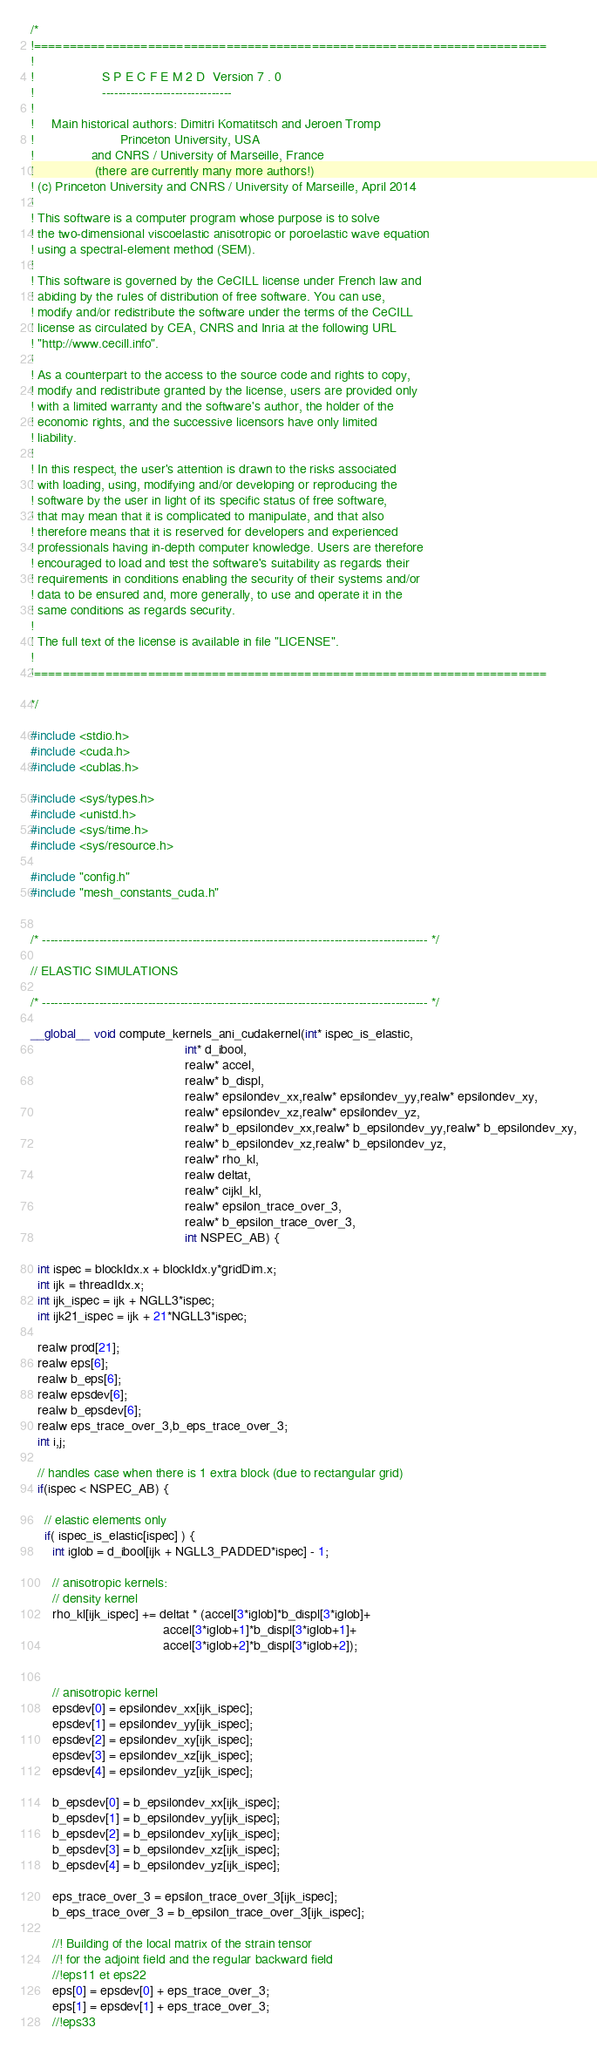Convert code to text. <code><loc_0><loc_0><loc_500><loc_500><_Cuda_>/*
!========================================================================
!
!                   S P E C F E M 2 D  Version 7 . 0
!                   --------------------------------
!
!     Main historical authors: Dimitri Komatitsch and Jeroen Tromp
!                        Princeton University, USA
!                and CNRS / University of Marseille, France
!                 (there are currently many more authors!)
! (c) Princeton University and CNRS / University of Marseille, April 2014
!
! This software is a computer program whose purpose is to solve
! the two-dimensional viscoelastic anisotropic or poroelastic wave equation
! using a spectral-element method (SEM).
!
! This software is governed by the CeCILL license under French law and
! abiding by the rules of distribution of free software. You can use,
! modify and/or redistribute the software under the terms of the CeCILL
! license as circulated by CEA, CNRS and Inria at the following URL
! "http://www.cecill.info".
!
! As a counterpart to the access to the source code and rights to copy,
! modify and redistribute granted by the license, users are provided only
! with a limited warranty and the software's author, the holder of the
! economic rights, and the successive licensors have only limited
! liability.
!
! In this respect, the user's attention is drawn to the risks associated
! with loading, using, modifying and/or developing or reproducing the
! software by the user in light of its specific status of free software,
! that may mean that it is complicated to manipulate, and that also
! therefore means that it is reserved for developers and experienced
! professionals having in-depth computer knowledge. Users are therefore
! encouraged to load and test the software's suitability as regards their
! requirements in conditions enabling the security of their systems and/or
! data to be ensured and, more generally, to use and operate it in the
! same conditions as regards security.
!
! The full text of the license is available in file "LICENSE".
!
!========================================================================

*/

#include <stdio.h>
#include <cuda.h>
#include <cublas.h>

#include <sys/types.h>
#include <unistd.h>
#include <sys/time.h>
#include <sys/resource.h>

#include "config.h"
#include "mesh_constants_cuda.h"


/* ----------------------------------------------------------------------------------------------- */

// ELASTIC SIMULATIONS

/* ----------------------------------------------------------------------------------------------- */

__global__ void compute_kernels_ani_cudakernel(int* ispec_is_elastic,
                                           int* d_ibool,
                                           realw* accel,
                                           realw* b_displ,
                                           realw* epsilondev_xx,realw* epsilondev_yy,realw* epsilondev_xy,
                                           realw* epsilondev_xz,realw* epsilondev_yz,
                                           realw* b_epsilondev_xx,realw* b_epsilondev_yy,realw* b_epsilondev_xy,
                                           realw* b_epsilondev_xz,realw* b_epsilondev_yz,
                                           realw* rho_kl,
                                           realw deltat,
                                           realw* cijkl_kl,
                                           realw* epsilon_trace_over_3,
                                           realw* b_epsilon_trace_over_3,
                                           int NSPEC_AB) {

  int ispec = blockIdx.x + blockIdx.y*gridDim.x;
  int ijk = threadIdx.x;
  int ijk_ispec = ijk + NGLL3*ispec;
  int ijk21_ispec = ijk + 21*NGLL3*ispec;

  realw prod[21];
  realw eps[6];
  realw b_eps[6];
  realw epsdev[6];
  realw b_epsdev[6];
  realw eps_trace_over_3,b_eps_trace_over_3;
  int i,j;

  // handles case when there is 1 extra block (due to rectangular grid)
  if(ispec < NSPEC_AB) {

    // elastic elements only
    if( ispec_is_elastic[ispec] ) {
      int iglob = d_ibool[ijk + NGLL3_PADDED*ispec] - 1;

      // anisotropic kernels:
      // density kernel
      rho_kl[ijk_ispec] += deltat * (accel[3*iglob]*b_displ[3*iglob]+
                                     accel[3*iglob+1]*b_displ[3*iglob+1]+
                                     accel[3*iglob+2]*b_displ[3*iglob+2]);


      // anisotropic kernel
      epsdev[0] = epsilondev_xx[ijk_ispec];
      epsdev[1] = epsilondev_yy[ijk_ispec];
      epsdev[2] = epsilondev_xy[ijk_ispec];
      epsdev[3] = epsilondev_xz[ijk_ispec];
      epsdev[4] = epsilondev_yz[ijk_ispec];

      b_epsdev[0] = b_epsilondev_xx[ijk_ispec];
      b_epsdev[1] = b_epsilondev_yy[ijk_ispec];
      b_epsdev[2] = b_epsilondev_xy[ijk_ispec];
      b_epsdev[3] = b_epsilondev_xz[ijk_ispec];
      b_epsdev[4] = b_epsilondev_yz[ijk_ispec];

      eps_trace_over_3 = epsilon_trace_over_3[ijk_ispec];
      b_eps_trace_over_3 = b_epsilon_trace_over_3[ijk_ispec];

      //! Building of the local matrix of the strain tensor
      //! for the adjoint field and the regular backward field
      //!eps11 et eps22
      eps[0] = epsdev[0] + eps_trace_over_3;
      eps[1] = epsdev[1] + eps_trace_over_3;
      //!eps33</code> 